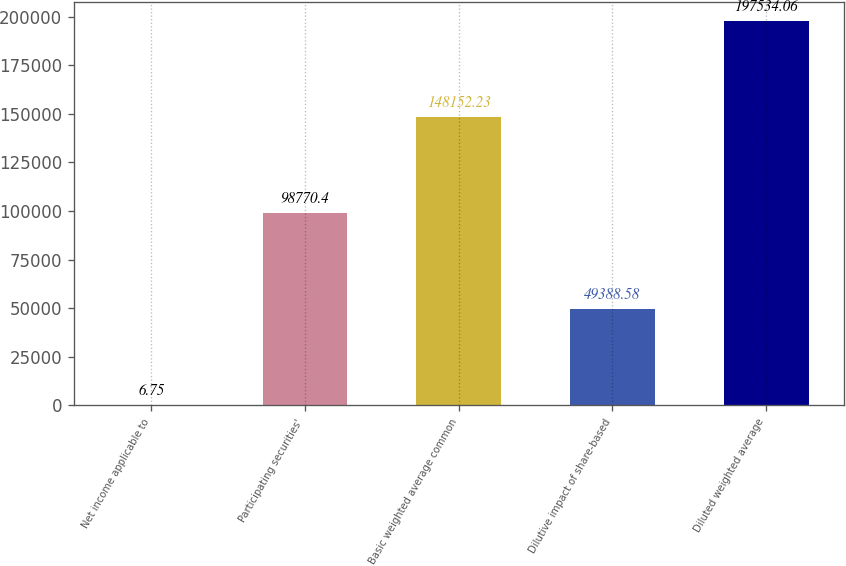<chart> <loc_0><loc_0><loc_500><loc_500><bar_chart><fcel>Net income applicable to<fcel>Participating securities'<fcel>Basic weighted average common<fcel>Dilutive impact of share-based<fcel>Diluted weighted average<nl><fcel>6.75<fcel>98770.4<fcel>148152<fcel>49388.6<fcel>197534<nl></chart> 